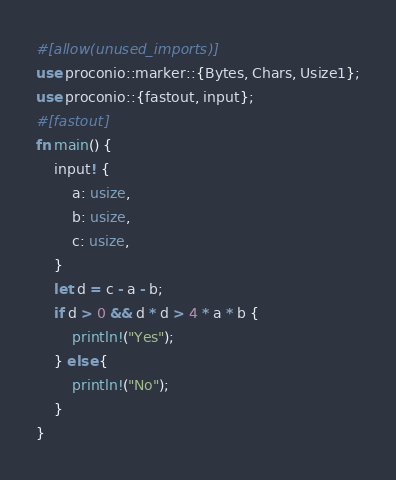Convert code to text. <code><loc_0><loc_0><loc_500><loc_500><_Rust_>#[allow(unused_imports)]
use proconio::marker::{Bytes, Chars, Usize1};
use proconio::{fastout, input};
#[fastout]
fn main() {
    input! {
        a: usize,
        b: usize,
        c: usize,
    }
    let d = c - a - b;
    if d > 0 && d * d > 4 * a * b {
        println!("Yes");
    } else {
        println!("No");
    }
}
</code> 